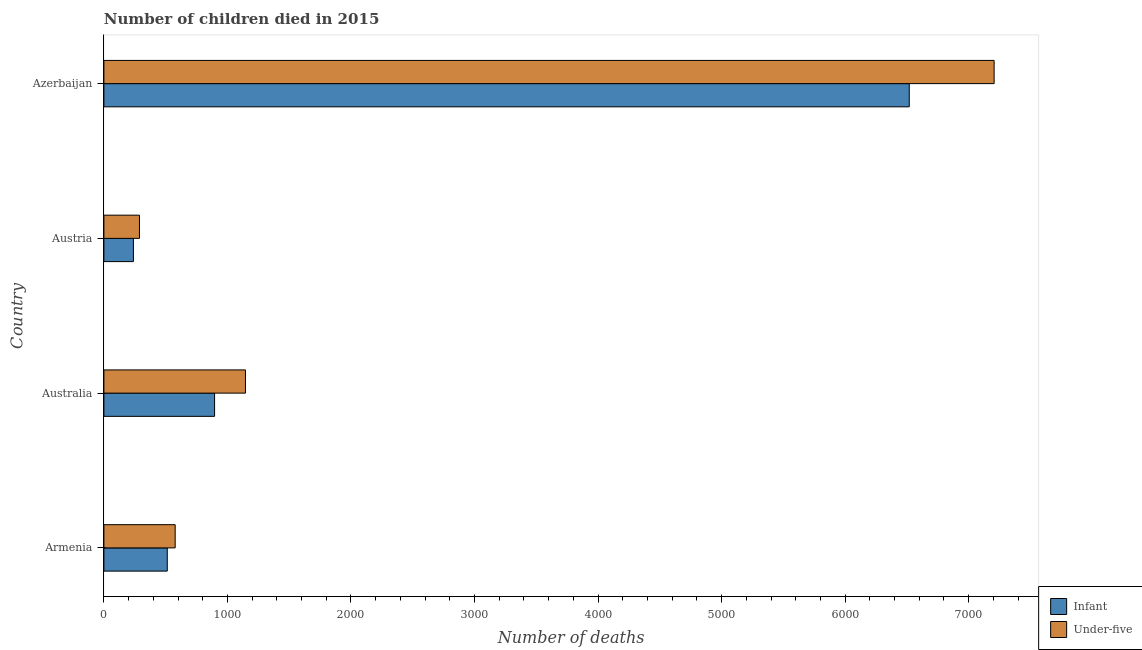How many bars are there on the 4th tick from the top?
Your answer should be very brief. 2. What is the label of the 3rd group of bars from the top?
Provide a succinct answer. Australia. What is the number of infant deaths in Austria?
Offer a terse response. 239. Across all countries, what is the maximum number of under-five deaths?
Your answer should be very brief. 7206. Across all countries, what is the minimum number of under-five deaths?
Provide a succinct answer. 288. In which country was the number of under-five deaths maximum?
Your response must be concise. Azerbaijan. What is the total number of under-five deaths in the graph?
Your response must be concise. 9217. What is the difference between the number of under-five deaths in Armenia and that in Azerbaijan?
Provide a short and direct response. -6629. What is the difference between the number of under-five deaths in Australia and the number of infant deaths in Austria?
Make the answer very short. 907. What is the average number of infant deaths per country?
Offer a terse response. 2041.75. What is the difference between the number of infant deaths and number of under-five deaths in Azerbaijan?
Ensure brevity in your answer.  -687. What is the ratio of the number of under-five deaths in Armenia to that in Austria?
Give a very brief answer. 2. Is the number of under-five deaths in Armenia less than that in Australia?
Give a very brief answer. Yes. Is the difference between the number of under-five deaths in Armenia and Austria greater than the difference between the number of infant deaths in Armenia and Austria?
Your answer should be compact. Yes. What is the difference between the highest and the second highest number of infant deaths?
Offer a terse response. 5623. What is the difference between the highest and the lowest number of infant deaths?
Your answer should be compact. 6280. Is the sum of the number of under-five deaths in Australia and Azerbaijan greater than the maximum number of infant deaths across all countries?
Ensure brevity in your answer.  Yes. What does the 2nd bar from the top in Australia represents?
Ensure brevity in your answer.  Infant. What does the 2nd bar from the bottom in Armenia represents?
Make the answer very short. Under-five. Are all the bars in the graph horizontal?
Offer a very short reply. Yes. Are the values on the major ticks of X-axis written in scientific E-notation?
Keep it short and to the point. No. Does the graph contain grids?
Your answer should be compact. No. Where does the legend appear in the graph?
Your answer should be compact. Bottom right. What is the title of the graph?
Provide a short and direct response. Number of children died in 2015. What is the label or title of the X-axis?
Your response must be concise. Number of deaths. What is the label or title of the Y-axis?
Keep it short and to the point. Country. What is the Number of deaths in Infant in Armenia?
Your answer should be very brief. 513. What is the Number of deaths of Under-five in Armenia?
Offer a terse response. 577. What is the Number of deaths in Infant in Australia?
Your response must be concise. 896. What is the Number of deaths of Under-five in Australia?
Your answer should be compact. 1146. What is the Number of deaths in Infant in Austria?
Your answer should be compact. 239. What is the Number of deaths in Under-five in Austria?
Your answer should be compact. 288. What is the Number of deaths in Infant in Azerbaijan?
Keep it short and to the point. 6519. What is the Number of deaths of Under-five in Azerbaijan?
Your answer should be very brief. 7206. Across all countries, what is the maximum Number of deaths in Infant?
Offer a very short reply. 6519. Across all countries, what is the maximum Number of deaths of Under-five?
Ensure brevity in your answer.  7206. Across all countries, what is the minimum Number of deaths in Infant?
Your answer should be compact. 239. Across all countries, what is the minimum Number of deaths in Under-five?
Ensure brevity in your answer.  288. What is the total Number of deaths in Infant in the graph?
Offer a terse response. 8167. What is the total Number of deaths in Under-five in the graph?
Provide a succinct answer. 9217. What is the difference between the Number of deaths in Infant in Armenia and that in Australia?
Provide a succinct answer. -383. What is the difference between the Number of deaths of Under-five in Armenia and that in Australia?
Give a very brief answer. -569. What is the difference between the Number of deaths of Infant in Armenia and that in Austria?
Provide a short and direct response. 274. What is the difference between the Number of deaths in Under-five in Armenia and that in Austria?
Make the answer very short. 289. What is the difference between the Number of deaths in Infant in Armenia and that in Azerbaijan?
Your response must be concise. -6006. What is the difference between the Number of deaths of Under-five in Armenia and that in Azerbaijan?
Your answer should be very brief. -6629. What is the difference between the Number of deaths of Infant in Australia and that in Austria?
Offer a very short reply. 657. What is the difference between the Number of deaths in Under-five in Australia and that in Austria?
Ensure brevity in your answer.  858. What is the difference between the Number of deaths of Infant in Australia and that in Azerbaijan?
Provide a succinct answer. -5623. What is the difference between the Number of deaths in Under-five in Australia and that in Azerbaijan?
Your answer should be compact. -6060. What is the difference between the Number of deaths of Infant in Austria and that in Azerbaijan?
Provide a succinct answer. -6280. What is the difference between the Number of deaths of Under-five in Austria and that in Azerbaijan?
Your response must be concise. -6918. What is the difference between the Number of deaths in Infant in Armenia and the Number of deaths in Under-five in Australia?
Your answer should be very brief. -633. What is the difference between the Number of deaths in Infant in Armenia and the Number of deaths in Under-five in Austria?
Your response must be concise. 225. What is the difference between the Number of deaths of Infant in Armenia and the Number of deaths of Under-five in Azerbaijan?
Your answer should be compact. -6693. What is the difference between the Number of deaths of Infant in Australia and the Number of deaths of Under-five in Austria?
Keep it short and to the point. 608. What is the difference between the Number of deaths of Infant in Australia and the Number of deaths of Under-five in Azerbaijan?
Ensure brevity in your answer.  -6310. What is the difference between the Number of deaths in Infant in Austria and the Number of deaths in Under-five in Azerbaijan?
Provide a short and direct response. -6967. What is the average Number of deaths in Infant per country?
Your answer should be very brief. 2041.75. What is the average Number of deaths of Under-five per country?
Provide a succinct answer. 2304.25. What is the difference between the Number of deaths of Infant and Number of deaths of Under-five in Armenia?
Make the answer very short. -64. What is the difference between the Number of deaths in Infant and Number of deaths in Under-five in Australia?
Your answer should be compact. -250. What is the difference between the Number of deaths of Infant and Number of deaths of Under-five in Austria?
Keep it short and to the point. -49. What is the difference between the Number of deaths of Infant and Number of deaths of Under-five in Azerbaijan?
Provide a succinct answer. -687. What is the ratio of the Number of deaths of Infant in Armenia to that in Australia?
Provide a succinct answer. 0.57. What is the ratio of the Number of deaths in Under-five in Armenia to that in Australia?
Provide a short and direct response. 0.5. What is the ratio of the Number of deaths of Infant in Armenia to that in Austria?
Offer a terse response. 2.15. What is the ratio of the Number of deaths of Under-five in Armenia to that in Austria?
Provide a succinct answer. 2. What is the ratio of the Number of deaths of Infant in Armenia to that in Azerbaijan?
Your response must be concise. 0.08. What is the ratio of the Number of deaths in Under-five in Armenia to that in Azerbaijan?
Provide a succinct answer. 0.08. What is the ratio of the Number of deaths of Infant in Australia to that in Austria?
Offer a terse response. 3.75. What is the ratio of the Number of deaths in Under-five in Australia to that in Austria?
Give a very brief answer. 3.98. What is the ratio of the Number of deaths of Infant in Australia to that in Azerbaijan?
Your response must be concise. 0.14. What is the ratio of the Number of deaths of Under-five in Australia to that in Azerbaijan?
Keep it short and to the point. 0.16. What is the ratio of the Number of deaths of Infant in Austria to that in Azerbaijan?
Offer a very short reply. 0.04. What is the ratio of the Number of deaths in Under-five in Austria to that in Azerbaijan?
Provide a succinct answer. 0.04. What is the difference between the highest and the second highest Number of deaths of Infant?
Your answer should be very brief. 5623. What is the difference between the highest and the second highest Number of deaths of Under-five?
Make the answer very short. 6060. What is the difference between the highest and the lowest Number of deaths of Infant?
Ensure brevity in your answer.  6280. What is the difference between the highest and the lowest Number of deaths in Under-five?
Ensure brevity in your answer.  6918. 